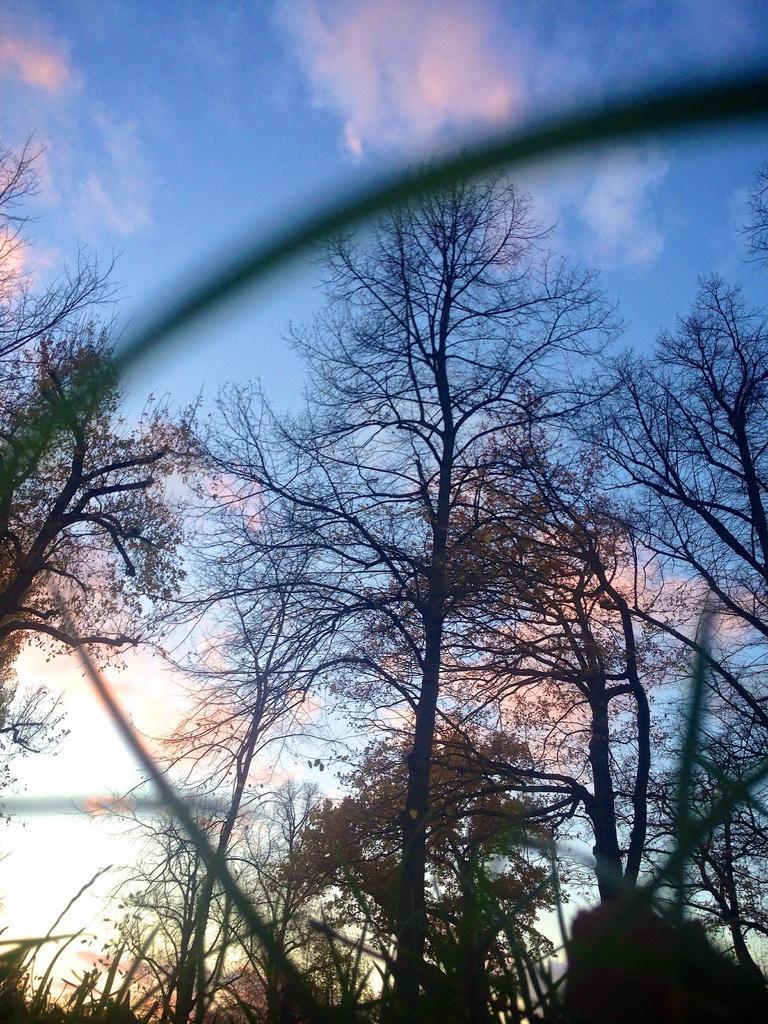How would you summarize this image in a sentence or two? In the picture I can see trees and some other objects. In the background I can see the sky. 